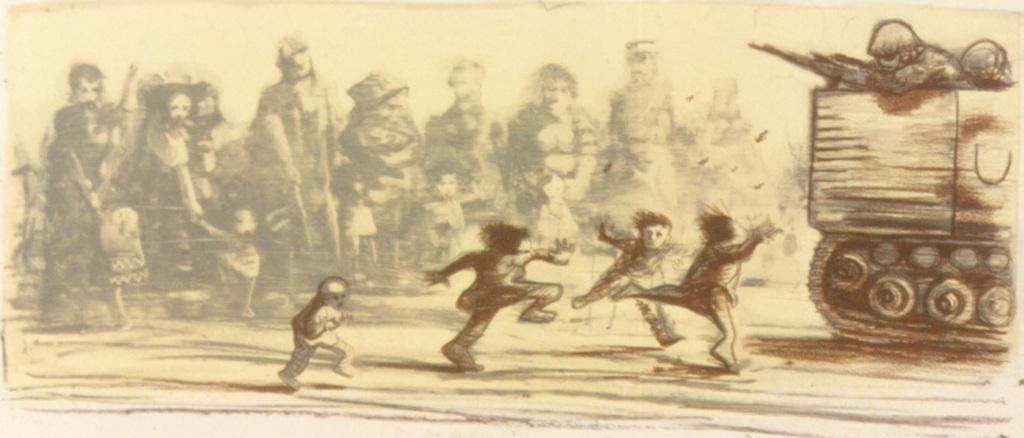What is the main object in the image? There is a drawing paper in the image. What activity is the small boy engaged in? The small boy is running and playing in the ground. Where is the military tank located in the image? The military tank is in the right corner of the image. What type of scent can be detected from the squirrel in the image? There is no squirrel present in the image, so it is not possible to detect any scent. 